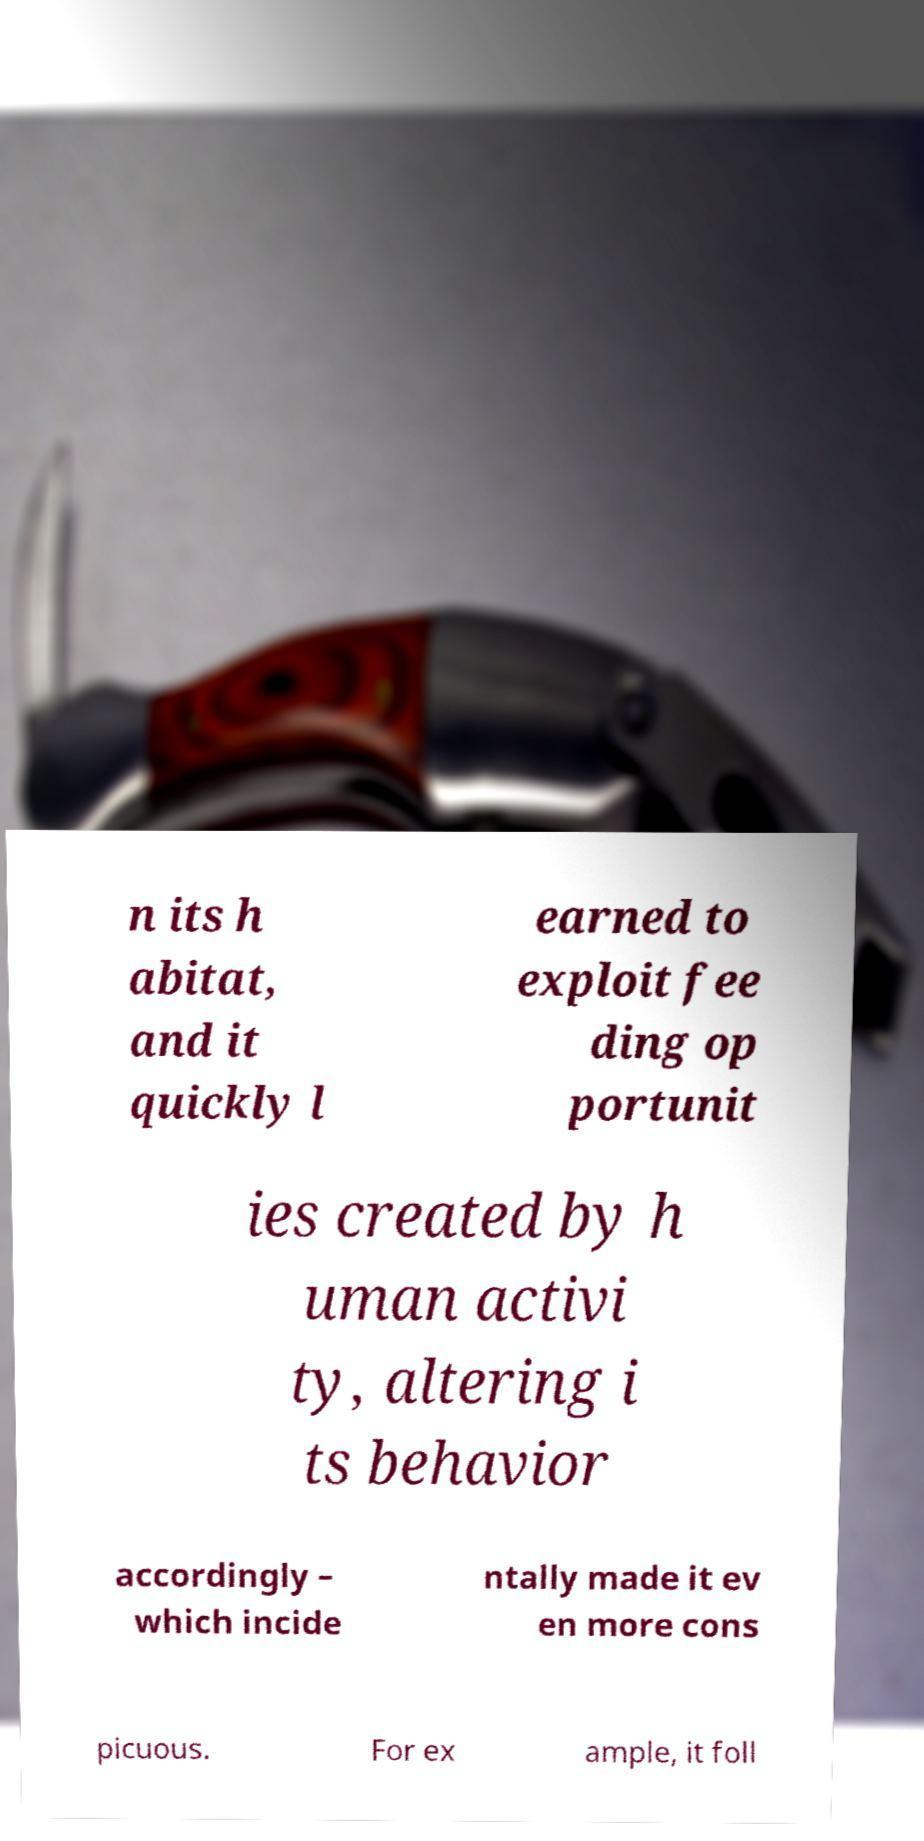Can you read and provide the text displayed in the image?This photo seems to have some interesting text. Can you extract and type it out for me? n its h abitat, and it quickly l earned to exploit fee ding op portunit ies created by h uman activi ty, altering i ts behavior accordingly – which incide ntally made it ev en more cons picuous. For ex ample, it foll 